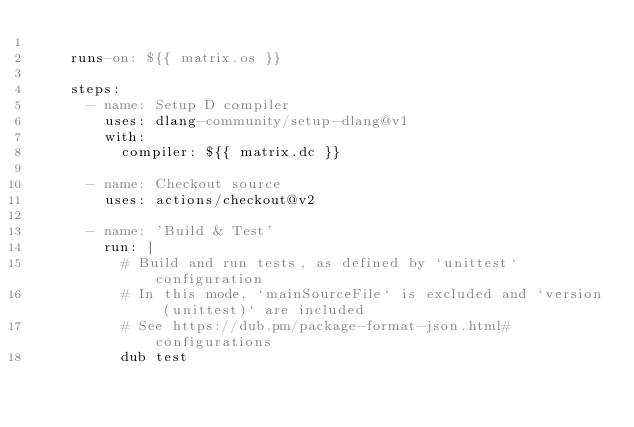<code> <loc_0><loc_0><loc_500><loc_500><_YAML_>
    runs-on: ${{ matrix.os }}

    steps:
      - name: Setup D compiler
        uses: dlang-community/setup-dlang@v1
        with:
          compiler: ${{ matrix.dc }}
          
      - name: Checkout source
        uses: actions/checkout@v2
        
      - name: 'Build & Test'
        run: |
          # Build and run tests, as defined by `unittest` configuration
          # In this mode, `mainSourceFile` is excluded and `version (unittest)` are included
          # See https://dub.pm/package-format-json.html#configurations
          dub test
</code> 